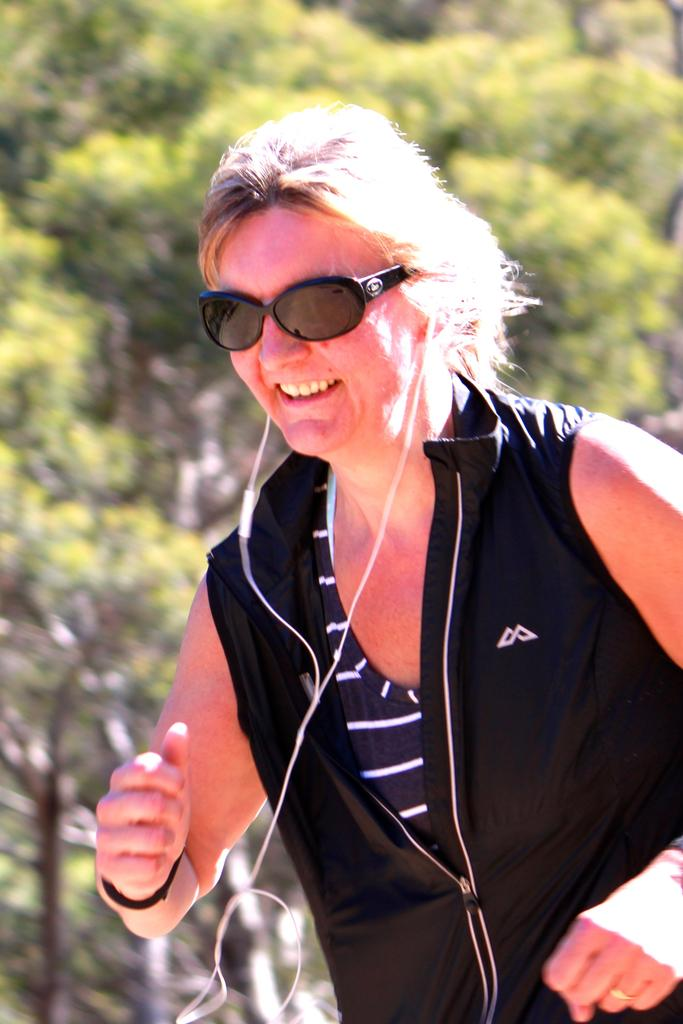Who is present in the image? There is a woman in the image. What is the woman doing in the image? The woman is standing in the image. What accessories is the woman wearing? The woman is wearing glasses and earphones. What can be seen in the background of the image? There are trees in the background of the image. What type of paint is the woman using to balance on the tree in the image? There is no paint or tree present in the image, and the woman is not balancing. 